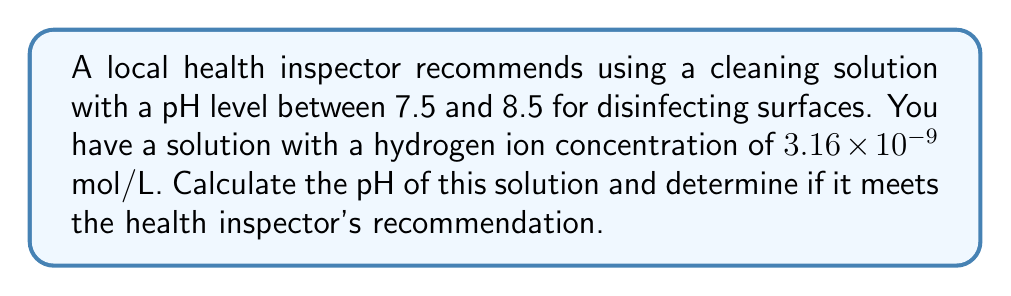Solve this math problem. To solve this problem, we'll use the following steps:

1) The pH of a solution is defined as the negative logarithm (base 10) of the hydrogen ion concentration [H+]:

   $$ pH = -\log_{10}[H^+] $$

2) We're given that [H+] = $3.16 \times 10^{-9}$ mol/L

3) Substituting this into the pH equation:

   $$ pH = -\log_{10}(3.16 \times 10^{-9}) $$

4) Using the properties of logarithms, we can simplify this:

   $$ pH = -(\log_{10}(3.16) + \log_{10}(10^{-9})) $$
   $$ pH = -(0.4997 - 9) $$
   $$ pH = -0.4997 + 9 $$
   $$ pH = 8.5003 $$

5) Rounding to two decimal places: pH = 8.50

6) The health inspector recommends a pH between 7.5 and 8.5.
   Since 8.50 is within this range (it's at the upper limit), the solution meets the recommendation.
Answer: pH = 8.50; meets recommendation 